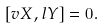<formula> <loc_0><loc_0><loc_500><loc_500>[ v X , l Y ] = 0 .</formula> 